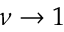<formula> <loc_0><loc_0><loc_500><loc_500>\nu \rightarrow 1</formula> 